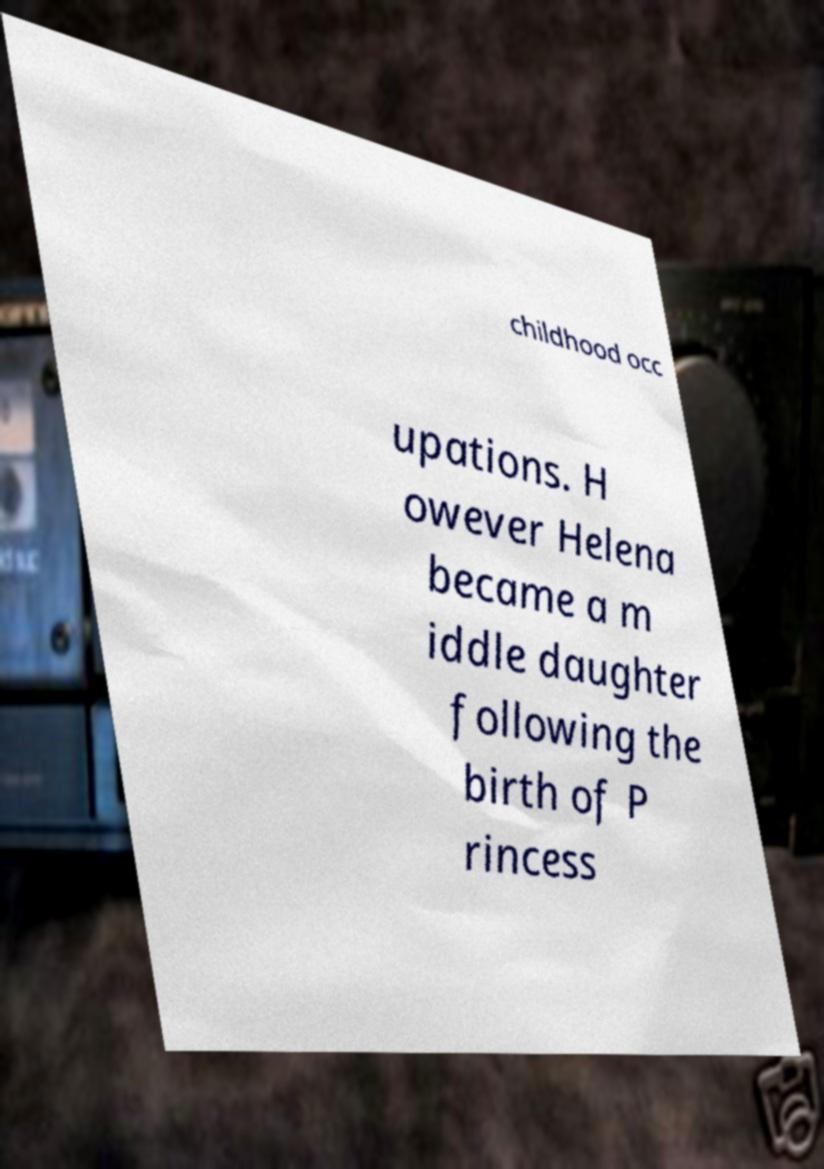There's text embedded in this image that I need extracted. Can you transcribe it verbatim? childhood occ upations. H owever Helena became a m iddle daughter following the birth of P rincess 